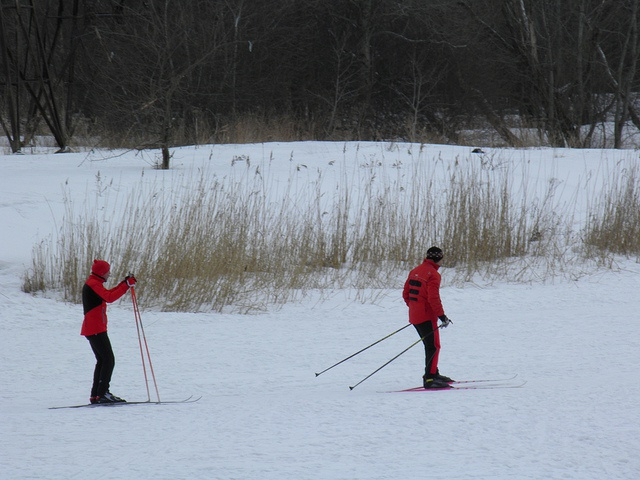Describe the objects in this image and their specific colors. I can see people in black, maroon, lightgray, and brown tones, people in black, maroon, and gray tones, skis in black, darkgray, and gray tones, and skis in black, darkgray, and lightgray tones in this image. 